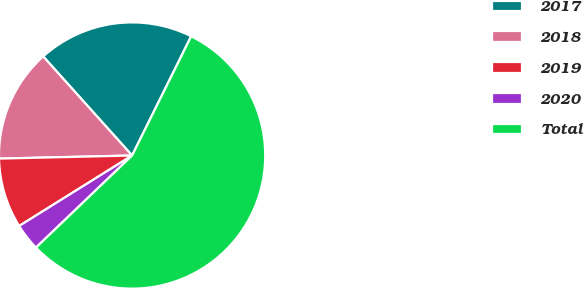<chart> <loc_0><loc_0><loc_500><loc_500><pie_chart><fcel>2017<fcel>2018<fcel>2019<fcel>2020<fcel>Total<nl><fcel>18.96%<fcel>13.73%<fcel>8.51%<fcel>3.28%<fcel>55.52%<nl></chart> 